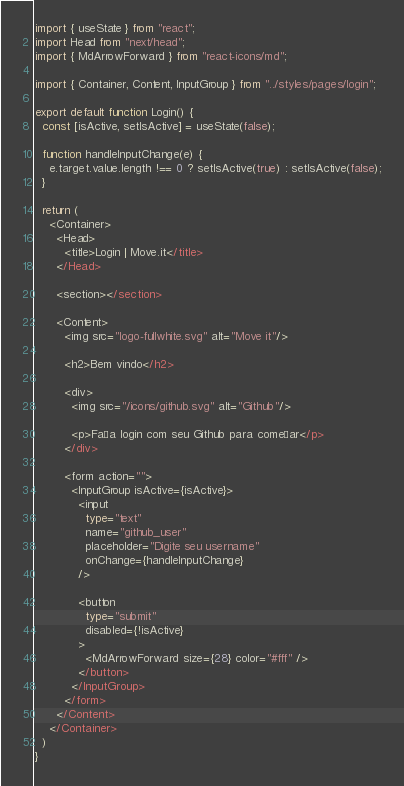Convert code to text. <code><loc_0><loc_0><loc_500><loc_500><_TypeScript_>import { useState } from "react";
import Head from "next/head";
import { MdArrowForward } from "react-icons/md";

import { Container, Content, InputGroup } from "../styles/pages/login";

export default function Login() {
  const [isActive, setIsActive] = useState(false);

  function handleInputChange(e) {
    e.target.value.length !== 0 ? setIsActive(true) : setIsActive(false);
  }

  return (
    <Container>
      <Head>
        <title>Login | Move.it</title>
      </Head>

      <section></section>

      <Content>
        <img src="logo-fullwhite.svg" alt="Move it"/>

        <h2>Bem vindo</h2>

        <div>
          <img src="/icons/github.svg" alt="Github"/>

          <p>Faça login com seu Github para começar</p>
        </div>

        <form action="">
          <InputGroup isActive={isActive}>
            <input 
              type="text" 
              name="github_user" 
              placeholder="Digite seu username" 
              onChange={handleInputChange}
            />

            <button 
              type="submit" 
              disabled={!isActive}
            >
              <MdArrowForward size={28} color="#fff" />
            </button>
          </InputGroup>
        </form>
      </Content>
    </Container>
  )
}</code> 